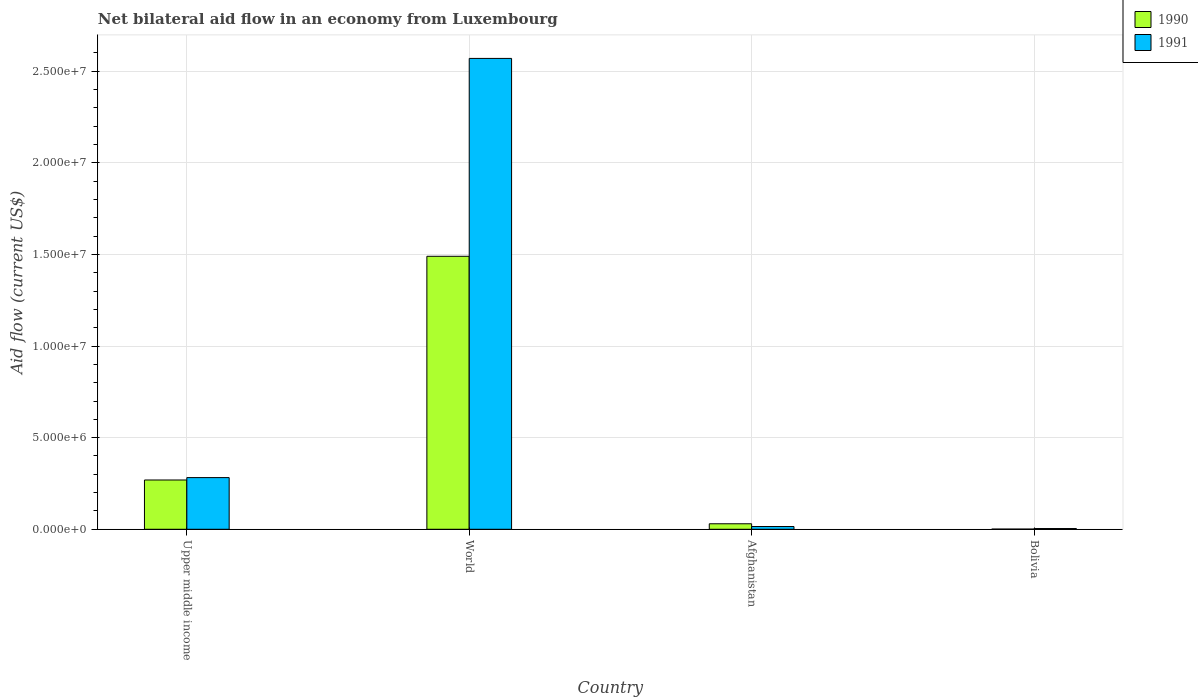Are the number of bars per tick equal to the number of legend labels?
Your response must be concise. Yes. Are the number of bars on each tick of the X-axis equal?
Your response must be concise. Yes. How many bars are there on the 2nd tick from the left?
Ensure brevity in your answer.  2. How many bars are there on the 2nd tick from the right?
Ensure brevity in your answer.  2. What is the label of the 4th group of bars from the left?
Provide a succinct answer. Bolivia. Across all countries, what is the maximum net bilateral aid flow in 1991?
Ensure brevity in your answer.  2.57e+07. Across all countries, what is the minimum net bilateral aid flow in 1990?
Offer a terse response. 10000. In which country was the net bilateral aid flow in 1991 maximum?
Keep it short and to the point. World. In which country was the net bilateral aid flow in 1991 minimum?
Keep it short and to the point. Bolivia. What is the total net bilateral aid flow in 1991 in the graph?
Your answer should be compact. 2.87e+07. What is the difference between the net bilateral aid flow in 1990 in Bolivia and that in Upper middle income?
Ensure brevity in your answer.  -2.68e+06. What is the difference between the net bilateral aid flow in 1991 in Upper middle income and the net bilateral aid flow in 1990 in Afghanistan?
Make the answer very short. 2.52e+06. What is the average net bilateral aid flow in 1991 per country?
Ensure brevity in your answer.  7.18e+06. What is the difference between the net bilateral aid flow of/in 1990 and net bilateral aid flow of/in 1991 in Bolivia?
Offer a terse response. -3.00e+04. In how many countries, is the net bilateral aid flow in 1990 greater than 16000000 US$?
Your response must be concise. 0. What is the ratio of the net bilateral aid flow in 1990 in Bolivia to that in World?
Your answer should be very brief. 0. Is the net bilateral aid flow in 1991 in Afghanistan less than that in World?
Keep it short and to the point. Yes. Is the difference between the net bilateral aid flow in 1990 in Afghanistan and Upper middle income greater than the difference between the net bilateral aid flow in 1991 in Afghanistan and Upper middle income?
Offer a very short reply. Yes. What is the difference between the highest and the second highest net bilateral aid flow in 1990?
Your answer should be compact. 1.46e+07. What is the difference between the highest and the lowest net bilateral aid flow in 1990?
Ensure brevity in your answer.  1.49e+07. What does the 2nd bar from the left in Afghanistan represents?
Ensure brevity in your answer.  1991. How many bars are there?
Your response must be concise. 8. How many countries are there in the graph?
Ensure brevity in your answer.  4. What is the difference between two consecutive major ticks on the Y-axis?
Make the answer very short. 5.00e+06. Are the values on the major ticks of Y-axis written in scientific E-notation?
Your answer should be compact. Yes. How many legend labels are there?
Offer a very short reply. 2. How are the legend labels stacked?
Keep it short and to the point. Vertical. What is the title of the graph?
Offer a very short reply. Net bilateral aid flow in an economy from Luxembourg. Does "1992" appear as one of the legend labels in the graph?
Your answer should be compact. No. What is the label or title of the Y-axis?
Make the answer very short. Aid flow (current US$). What is the Aid flow (current US$) in 1990 in Upper middle income?
Your response must be concise. 2.69e+06. What is the Aid flow (current US$) of 1991 in Upper middle income?
Provide a short and direct response. 2.82e+06. What is the Aid flow (current US$) in 1990 in World?
Offer a very short reply. 1.49e+07. What is the Aid flow (current US$) in 1991 in World?
Give a very brief answer. 2.57e+07. What is the Aid flow (current US$) of 1990 in Afghanistan?
Your answer should be very brief. 3.00e+05. What is the Aid flow (current US$) in 1990 in Bolivia?
Offer a terse response. 10000. What is the Aid flow (current US$) of 1991 in Bolivia?
Make the answer very short. 4.00e+04. Across all countries, what is the maximum Aid flow (current US$) in 1990?
Provide a short and direct response. 1.49e+07. Across all countries, what is the maximum Aid flow (current US$) in 1991?
Keep it short and to the point. 2.57e+07. Across all countries, what is the minimum Aid flow (current US$) in 1991?
Keep it short and to the point. 4.00e+04. What is the total Aid flow (current US$) in 1990 in the graph?
Make the answer very short. 1.79e+07. What is the total Aid flow (current US$) of 1991 in the graph?
Your answer should be very brief. 2.87e+07. What is the difference between the Aid flow (current US$) of 1990 in Upper middle income and that in World?
Offer a terse response. -1.22e+07. What is the difference between the Aid flow (current US$) of 1991 in Upper middle income and that in World?
Offer a very short reply. -2.29e+07. What is the difference between the Aid flow (current US$) in 1990 in Upper middle income and that in Afghanistan?
Offer a terse response. 2.39e+06. What is the difference between the Aid flow (current US$) of 1991 in Upper middle income and that in Afghanistan?
Give a very brief answer. 2.67e+06. What is the difference between the Aid flow (current US$) in 1990 in Upper middle income and that in Bolivia?
Keep it short and to the point. 2.68e+06. What is the difference between the Aid flow (current US$) in 1991 in Upper middle income and that in Bolivia?
Your answer should be compact. 2.78e+06. What is the difference between the Aid flow (current US$) of 1990 in World and that in Afghanistan?
Offer a terse response. 1.46e+07. What is the difference between the Aid flow (current US$) of 1991 in World and that in Afghanistan?
Your response must be concise. 2.56e+07. What is the difference between the Aid flow (current US$) in 1990 in World and that in Bolivia?
Give a very brief answer. 1.49e+07. What is the difference between the Aid flow (current US$) in 1991 in World and that in Bolivia?
Provide a succinct answer. 2.57e+07. What is the difference between the Aid flow (current US$) in 1990 in Afghanistan and that in Bolivia?
Keep it short and to the point. 2.90e+05. What is the difference between the Aid flow (current US$) of 1991 in Afghanistan and that in Bolivia?
Your answer should be very brief. 1.10e+05. What is the difference between the Aid flow (current US$) in 1990 in Upper middle income and the Aid flow (current US$) in 1991 in World?
Your answer should be very brief. -2.30e+07. What is the difference between the Aid flow (current US$) in 1990 in Upper middle income and the Aid flow (current US$) in 1991 in Afghanistan?
Offer a terse response. 2.54e+06. What is the difference between the Aid flow (current US$) of 1990 in Upper middle income and the Aid flow (current US$) of 1991 in Bolivia?
Provide a short and direct response. 2.65e+06. What is the difference between the Aid flow (current US$) in 1990 in World and the Aid flow (current US$) in 1991 in Afghanistan?
Keep it short and to the point. 1.48e+07. What is the difference between the Aid flow (current US$) of 1990 in World and the Aid flow (current US$) of 1991 in Bolivia?
Your answer should be compact. 1.49e+07. What is the difference between the Aid flow (current US$) in 1990 in Afghanistan and the Aid flow (current US$) in 1991 in Bolivia?
Ensure brevity in your answer.  2.60e+05. What is the average Aid flow (current US$) in 1990 per country?
Your answer should be very brief. 4.48e+06. What is the average Aid flow (current US$) in 1991 per country?
Your response must be concise. 7.18e+06. What is the difference between the Aid flow (current US$) of 1990 and Aid flow (current US$) of 1991 in Upper middle income?
Make the answer very short. -1.30e+05. What is the difference between the Aid flow (current US$) in 1990 and Aid flow (current US$) in 1991 in World?
Keep it short and to the point. -1.08e+07. What is the difference between the Aid flow (current US$) in 1990 and Aid flow (current US$) in 1991 in Afghanistan?
Ensure brevity in your answer.  1.50e+05. What is the ratio of the Aid flow (current US$) in 1990 in Upper middle income to that in World?
Provide a short and direct response. 0.18. What is the ratio of the Aid flow (current US$) of 1991 in Upper middle income to that in World?
Offer a very short reply. 0.11. What is the ratio of the Aid flow (current US$) of 1990 in Upper middle income to that in Afghanistan?
Your response must be concise. 8.97. What is the ratio of the Aid flow (current US$) of 1990 in Upper middle income to that in Bolivia?
Ensure brevity in your answer.  269. What is the ratio of the Aid flow (current US$) in 1991 in Upper middle income to that in Bolivia?
Provide a succinct answer. 70.5. What is the ratio of the Aid flow (current US$) in 1990 in World to that in Afghanistan?
Give a very brief answer. 49.67. What is the ratio of the Aid flow (current US$) in 1991 in World to that in Afghanistan?
Make the answer very short. 171.33. What is the ratio of the Aid flow (current US$) in 1990 in World to that in Bolivia?
Provide a short and direct response. 1490. What is the ratio of the Aid flow (current US$) of 1991 in World to that in Bolivia?
Ensure brevity in your answer.  642.5. What is the ratio of the Aid flow (current US$) in 1990 in Afghanistan to that in Bolivia?
Provide a short and direct response. 30. What is the ratio of the Aid flow (current US$) in 1991 in Afghanistan to that in Bolivia?
Make the answer very short. 3.75. What is the difference between the highest and the second highest Aid flow (current US$) in 1990?
Offer a very short reply. 1.22e+07. What is the difference between the highest and the second highest Aid flow (current US$) of 1991?
Your response must be concise. 2.29e+07. What is the difference between the highest and the lowest Aid flow (current US$) in 1990?
Give a very brief answer. 1.49e+07. What is the difference between the highest and the lowest Aid flow (current US$) of 1991?
Your response must be concise. 2.57e+07. 